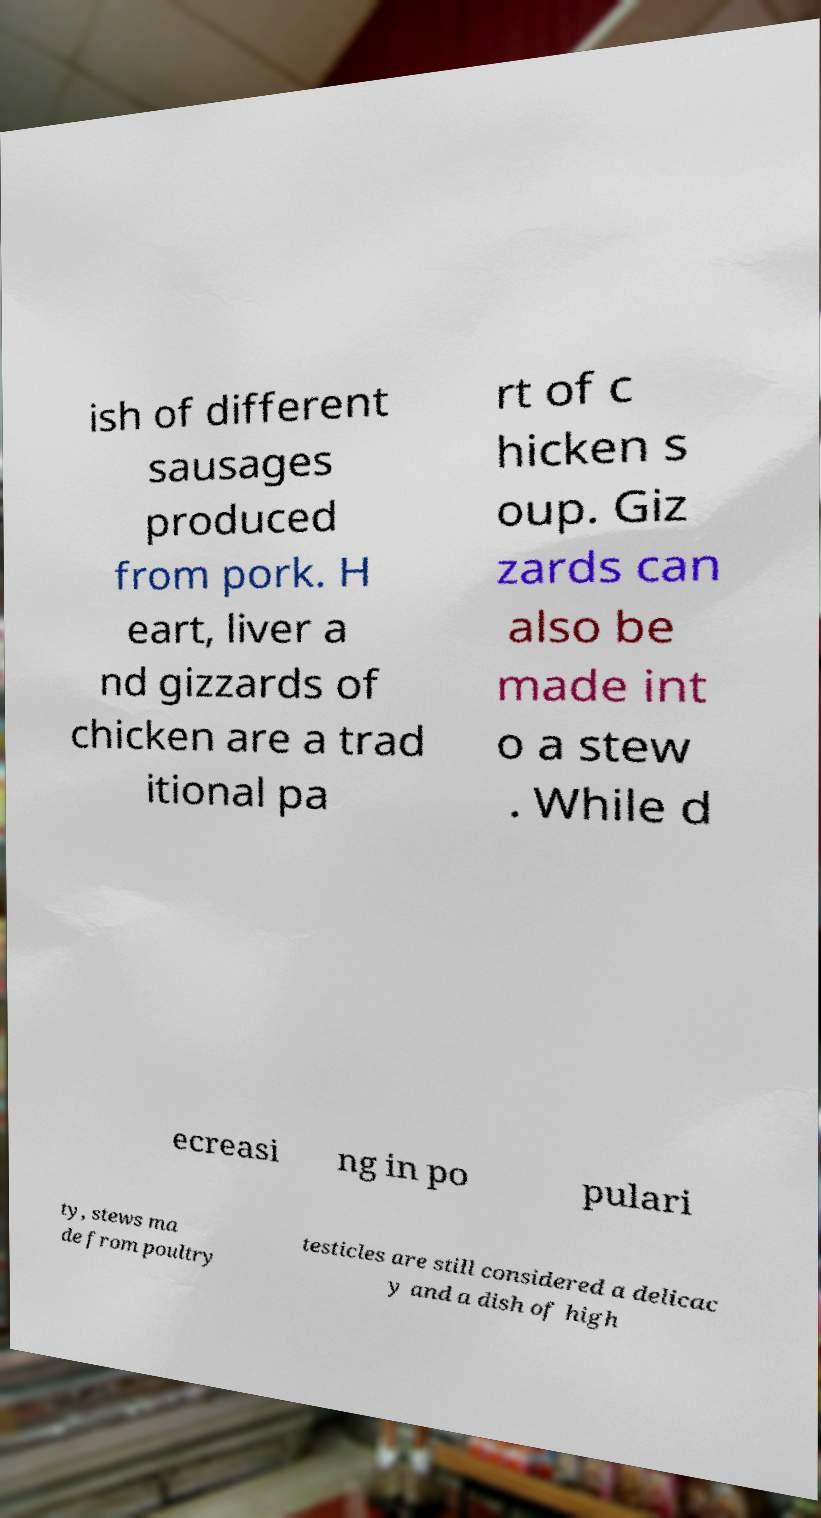For documentation purposes, I need the text within this image transcribed. Could you provide that? ish of different sausages produced from pork. H eart, liver a nd gizzards of chicken are a trad itional pa rt of c hicken s oup. Giz zards can also be made int o a stew . While d ecreasi ng in po pulari ty, stews ma de from poultry testicles are still considered a delicac y and a dish of high 